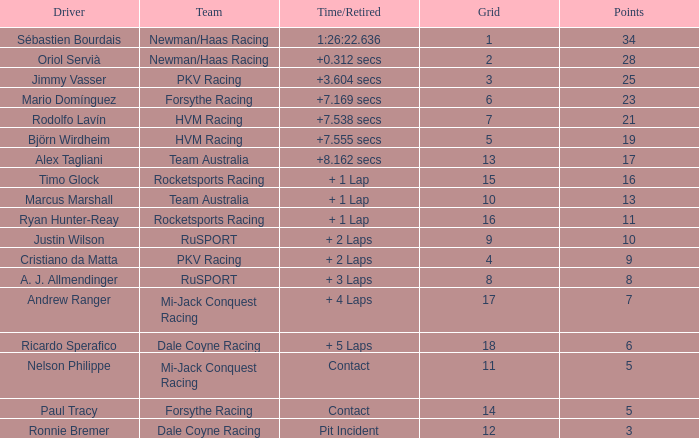What is the name of the operator with 6 points? Ricardo Sperafico. 